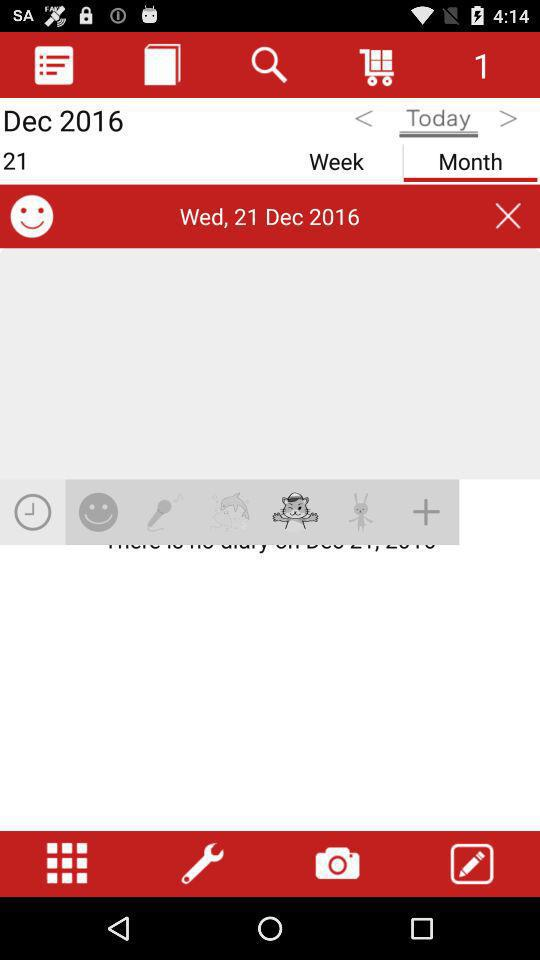What is the date?
Answer the question using a single word or phrase. Wed, 21 Dec 2016 